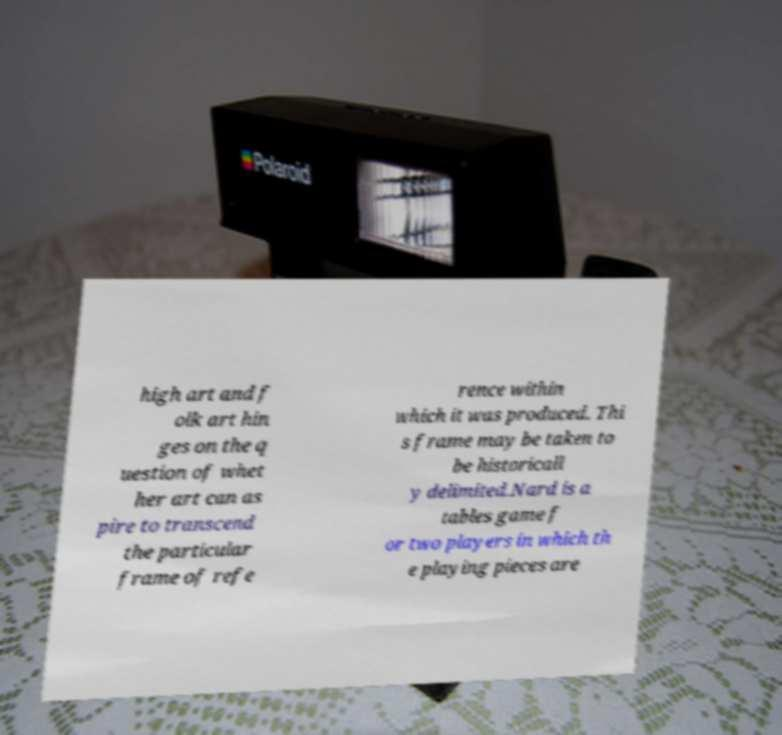For documentation purposes, I need the text within this image transcribed. Could you provide that? high art and f olk art hin ges on the q uestion of whet her art can as pire to transcend the particular frame of refe rence within which it was produced. Thi s frame may be taken to be historicall y delimited.Nard is a tables game f or two players in which th e playing pieces are 